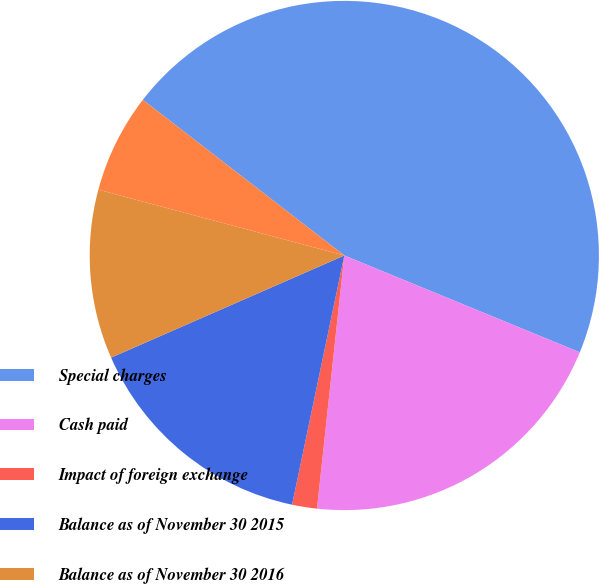Convert chart. <chart><loc_0><loc_0><loc_500><loc_500><pie_chart><fcel>Special charges<fcel>Cash paid<fcel>Impact of foreign exchange<fcel>Balance as of November 30 2015<fcel>Balance as of November 30 2016<fcel>Balance as of November 30 2017<nl><fcel>45.74%<fcel>20.5%<fcel>1.58%<fcel>15.14%<fcel>10.73%<fcel>6.31%<nl></chart> 